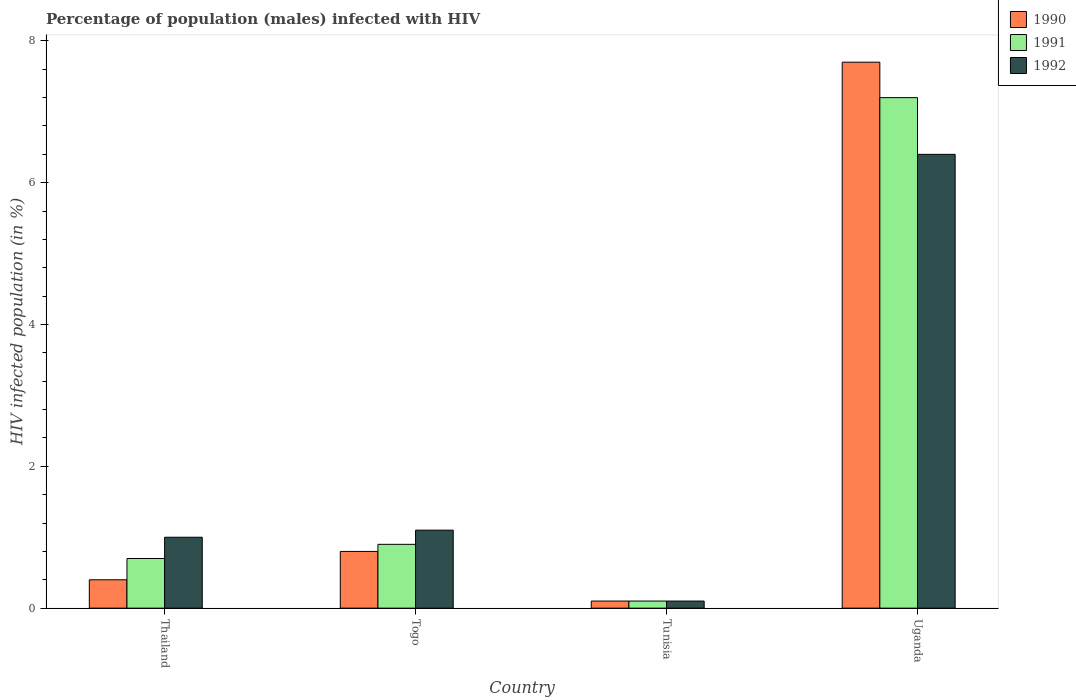How many different coloured bars are there?
Your response must be concise. 3. How many bars are there on the 4th tick from the right?
Your answer should be compact. 3. What is the label of the 4th group of bars from the left?
Give a very brief answer. Uganda. Across all countries, what is the maximum percentage of HIV infected male population in 1992?
Your answer should be compact. 6.4. In which country was the percentage of HIV infected male population in 1992 maximum?
Your answer should be very brief. Uganda. In which country was the percentage of HIV infected male population in 1992 minimum?
Your response must be concise. Tunisia. What is the total percentage of HIV infected male population in 1992 in the graph?
Keep it short and to the point. 8.6. What is the difference between the percentage of HIV infected male population in 1992 in Thailand and that in Uganda?
Make the answer very short. -5.4. What is the average percentage of HIV infected male population in 1991 per country?
Keep it short and to the point. 2.23. What is the difference between the percentage of HIV infected male population of/in 1990 and percentage of HIV infected male population of/in 1991 in Togo?
Provide a short and direct response. -0.1. In how many countries, is the percentage of HIV infected male population in 1991 greater than 5.2 %?
Keep it short and to the point. 1. What is the ratio of the percentage of HIV infected male population in 1991 in Thailand to that in Togo?
Offer a very short reply. 0.78. What is the difference between the highest and the second highest percentage of HIV infected male population in 1992?
Offer a terse response. -5.3. What is the difference between the highest and the lowest percentage of HIV infected male population in 1991?
Ensure brevity in your answer.  7.1. In how many countries, is the percentage of HIV infected male population in 1992 greater than the average percentage of HIV infected male population in 1992 taken over all countries?
Offer a terse response. 1. What does the 2nd bar from the left in Uganda represents?
Ensure brevity in your answer.  1991. What does the 1st bar from the right in Uganda represents?
Make the answer very short. 1992. How many countries are there in the graph?
Offer a terse response. 4. Are the values on the major ticks of Y-axis written in scientific E-notation?
Offer a terse response. No. How many legend labels are there?
Ensure brevity in your answer.  3. What is the title of the graph?
Ensure brevity in your answer.  Percentage of population (males) infected with HIV. What is the label or title of the Y-axis?
Offer a very short reply. HIV infected population (in %). What is the HIV infected population (in %) in 1990 in Thailand?
Make the answer very short. 0.4. What is the HIV infected population (in %) in 1991 in Thailand?
Give a very brief answer. 0.7. What is the HIV infected population (in %) in 1992 in Uganda?
Provide a succinct answer. 6.4. Across all countries, what is the maximum HIV infected population (in %) in 1991?
Your answer should be compact. 7.2. Across all countries, what is the maximum HIV infected population (in %) in 1992?
Your answer should be compact. 6.4. Across all countries, what is the minimum HIV infected population (in %) of 1990?
Provide a short and direct response. 0.1. Across all countries, what is the minimum HIV infected population (in %) in 1991?
Make the answer very short. 0.1. What is the total HIV infected population (in %) in 1990 in the graph?
Offer a terse response. 9. What is the difference between the HIV infected population (in %) of 1990 in Thailand and that in Togo?
Give a very brief answer. -0.4. What is the difference between the HIV infected population (in %) in 1991 in Thailand and that in Togo?
Offer a terse response. -0.2. What is the difference between the HIV infected population (in %) in 1992 in Thailand and that in Togo?
Offer a very short reply. -0.1. What is the difference between the HIV infected population (in %) of 1991 in Thailand and that in Uganda?
Give a very brief answer. -6.5. What is the difference between the HIV infected population (in %) of 1992 in Thailand and that in Uganda?
Ensure brevity in your answer.  -5.4. What is the difference between the HIV infected population (in %) of 1990 in Togo and that in Tunisia?
Offer a very short reply. 0.7. What is the difference between the HIV infected population (in %) in 1990 in Togo and that in Uganda?
Your answer should be compact. -6.9. What is the difference between the HIV infected population (in %) of 1991 in Togo and that in Uganda?
Keep it short and to the point. -6.3. What is the difference between the HIV infected population (in %) in 1992 in Togo and that in Uganda?
Offer a very short reply. -5.3. What is the difference between the HIV infected population (in %) in 1991 in Tunisia and that in Uganda?
Give a very brief answer. -7.1. What is the difference between the HIV infected population (in %) of 1992 in Tunisia and that in Uganda?
Give a very brief answer. -6.3. What is the difference between the HIV infected population (in %) of 1991 in Thailand and the HIV infected population (in %) of 1992 in Togo?
Your response must be concise. -0.4. What is the difference between the HIV infected population (in %) in 1990 in Thailand and the HIV infected population (in %) in 1991 in Tunisia?
Offer a very short reply. 0.3. What is the difference between the HIV infected population (in %) in 1990 in Thailand and the HIV infected population (in %) in 1992 in Tunisia?
Your response must be concise. 0.3. What is the difference between the HIV infected population (in %) in 1990 in Thailand and the HIV infected population (in %) in 1992 in Uganda?
Your response must be concise. -6. What is the difference between the HIV infected population (in %) in 1991 in Thailand and the HIV infected population (in %) in 1992 in Uganda?
Keep it short and to the point. -5.7. What is the difference between the HIV infected population (in %) in 1990 in Togo and the HIV infected population (in %) in 1991 in Tunisia?
Ensure brevity in your answer.  0.7. What is the difference between the HIV infected population (in %) in 1990 in Togo and the HIV infected population (in %) in 1992 in Tunisia?
Give a very brief answer. 0.7. What is the difference between the HIV infected population (in %) in 1991 in Togo and the HIV infected population (in %) in 1992 in Tunisia?
Offer a terse response. 0.8. What is the difference between the HIV infected population (in %) of 1990 in Togo and the HIV infected population (in %) of 1991 in Uganda?
Offer a very short reply. -6.4. What is the difference between the HIV infected population (in %) of 1990 in Tunisia and the HIV infected population (in %) of 1992 in Uganda?
Keep it short and to the point. -6.3. What is the difference between the HIV infected population (in %) of 1991 in Tunisia and the HIV infected population (in %) of 1992 in Uganda?
Give a very brief answer. -6.3. What is the average HIV infected population (in %) in 1990 per country?
Make the answer very short. 2.25. What is the average HIV infected population (in %) in 1991 per country?
Provide a succinct answer. 2.23. What is the average HIV infected population (in %) of 1992 per country?
Your answer should be very brief. 2.15. What is the difference between the HIV infected population (in %) in 1990 and HIV infected population (in %) in 1992 in Thailand?
Keep it short and to the point. -0.6. What is the difference between the HIV infected population (in %) in 1991 and HIV infected population (in %) in 1992 in Togo?
Offer a very short reply. -0.2. What is the ratio of the HIV infected population (in %) of 1991 in Thailand to that in Togo?
Provide a short and direct response. 0.78. What is the ratio of the HIV infected population (in %) of 1992 in Thailand to that in Togo?
Give a very brief answer. 0.91. What is the ratio of the HIV infected population (in %) in 1992 in Thailand to that in Tunisia?
Your answer should be compact. 10. What is the ratio of the HIV infected population (in %) of 1990 in Thailand to that in Uganda?
Offer a terse response. 0.05. What is the ratio of the HIV infected population (in %) of 1991 in Thailand to that in Uganda?
Your answer should be very brief. 0.1. What is the ratio of the HIV infected population (in %) in 1992 in Thailand to that in Uganda?
Offer a terse response. 0.16. What is the ratio of the HIV infected population (in %) in 1990 in Togo to that in Uganda?
Provide a short and direct response. 0.1. What is the ratio of the HIV infected population (in %) in 1992 in Togo to that in Uganda?
Provide a succinct answer. 0.17. What is the ratio of the HIV infected population (in %) of 1990 in Tunisia to that in Uganda?
Provide a short and direct response. 0.01. What is the ratio of the HIV infected population (in %) in 1991 in Tunisia to that in Uganda?
Keep it short and to the point. 0.01. What is the ratio of the HIV infected population (in %) in 1992 in Tunisia to that in Uganda?
Your response must be concise. 0.02. What is the difference between the highest and the second highest HIV infected population (in %) of 1990?
Give a very brief answer. 6.9. What is the difference between the highest and the second highest HIV infected population (in %) of 1991?
Offer a terse response. 6.3. What is the difference between the highest and the second highest HIV infected population (in %) in 1992?
Your answer should be very brief. 5.3. What is the difference between the highest and the lowest HIV infected population (in %) in 1991?
Your answer should be very brief. 7.1. What is the difference between the highest and the lowest HIV infected population (in %) in 1992?
Give a very brief answer. 6.3. 